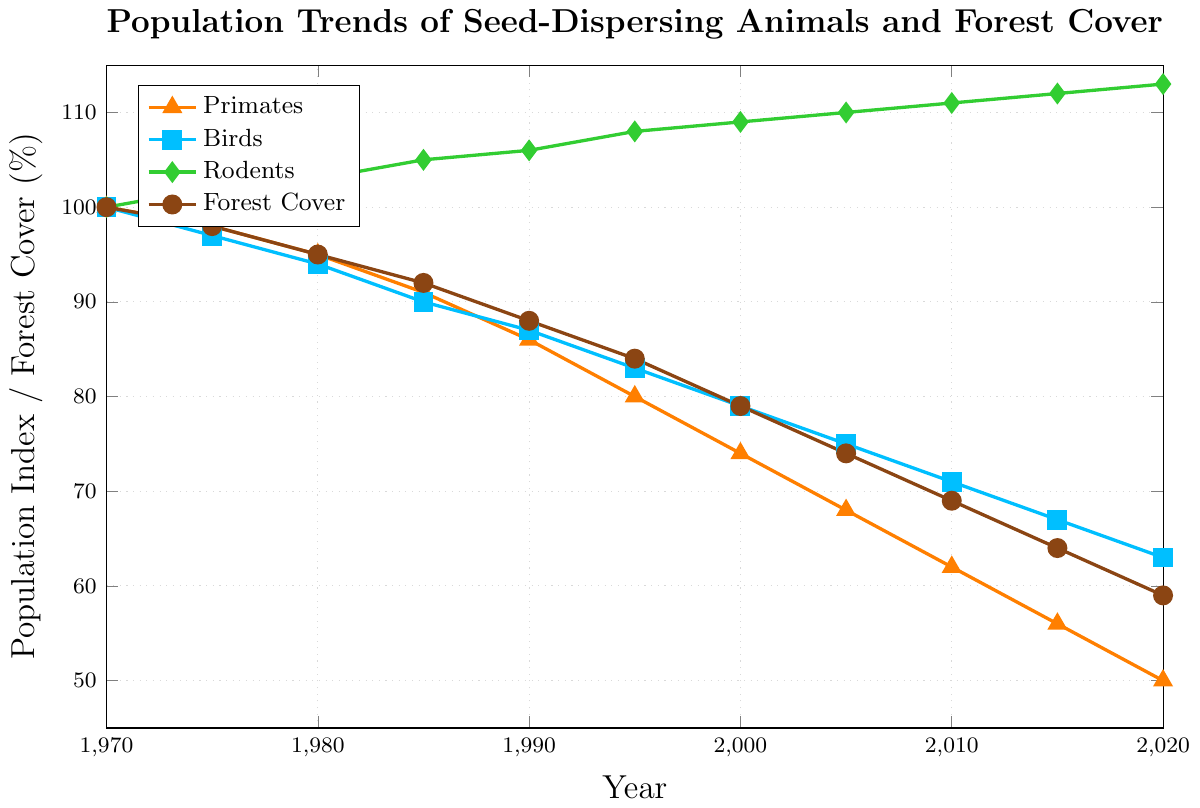What's the trend of the primates' population over the 50 years? From 1970 to 2020, the primates' population has consistently decreased. It started from an index of 100 in 1970 and fell to 50 in 2020.
Answer: Consistently decreased Which group of animals increased in population over the 50 years? Among the three groups, rodents show an increasing trend in population. Their index rose from 100 in 1970 to 113 in 2020.
Answer: Rodents What's the difference in forest cover percentage between 1970 and 2020? The forest cover percentage has decreased from 100% in 1970 to 59% in 2020. To find the difference: 100 - 59.
Answer: 41% Between birds and primates, which group experienced a greater decline by 2020? Primates dropped from 100 to 50, i.e., a decline of 50. Birds dropped from 100 to 63, i.e., a decline of 37. Primates experienced a greater decline.
Answer: Primates In which year did the forest cover drop below 70%? We observe the forest cover falling below 70% in the year 2010 where it's 69%.
Answer: 2010 Compare the population trend of birds and primates in 1995. In 1995, birds had a population index of 83, while the primates had an index of 80, indicating that birds were higher than primates in that year.
Answer: Birds were higher How does the rodents' population index in 2020 compare to their index in 1975? In 1975, the rodents' population index was 102, and in 2020 it was 113, showing an increase.
Answer: Increased What is the average population index of primates in the years 1990, 2000, and 2010? The indices are 86 (1990), 74 (2000), and 62 (2010). Sum: 86 + 74 + 62 = 222. Average: 222 / 3.
Answer: 74 Did any group's population remain almost constant over the years? Yes, the population of rodents remained almost constant with a slight increasing trend, from an index of 100 in 1970 to 113 in 2020.
Answer: Rodents Which species had the lowest population index in 2020? The group with the lowest population index in 2020 is primates with an index of 50.
Answer: Primates 